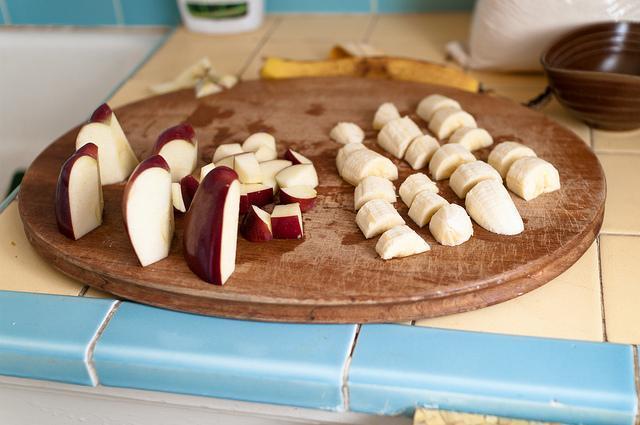How many apples are there?
Give a very brief answer. 5. How many bananas are visible?
Give a very brief answer. 4. 